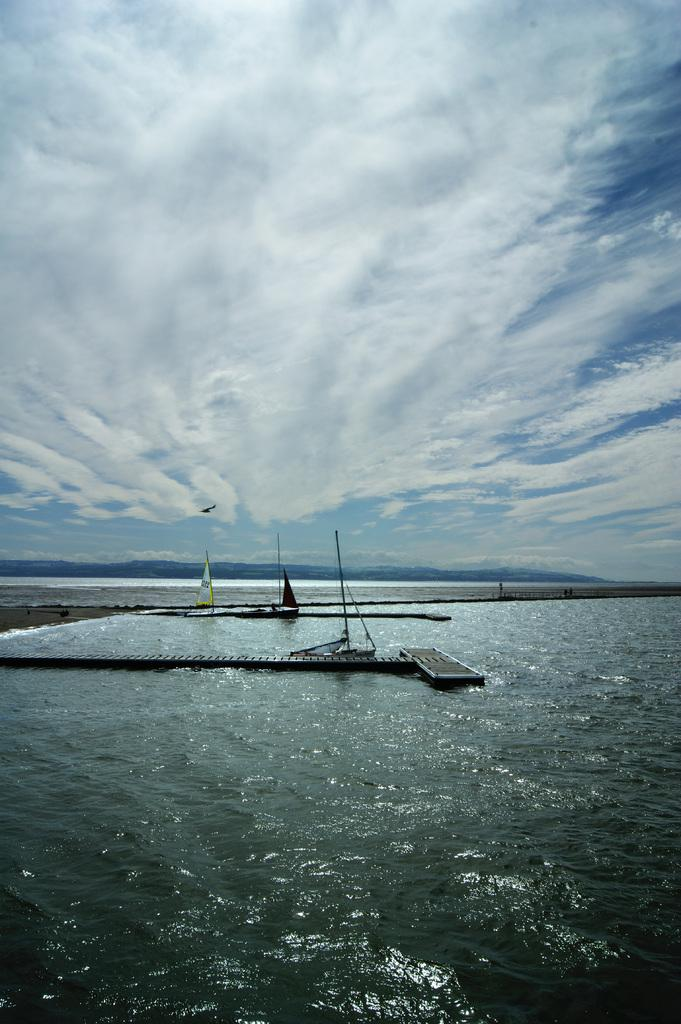What can be seen in the image? There is water visible in the image. What structure is present in the image? There is a platform in the image. What is visible in the background of the image? The sky is visible in the background of the image. How many friends are present on the platform in the image? There is no mention of friends or any people in the image; it only features water, a platform, and the sky. 